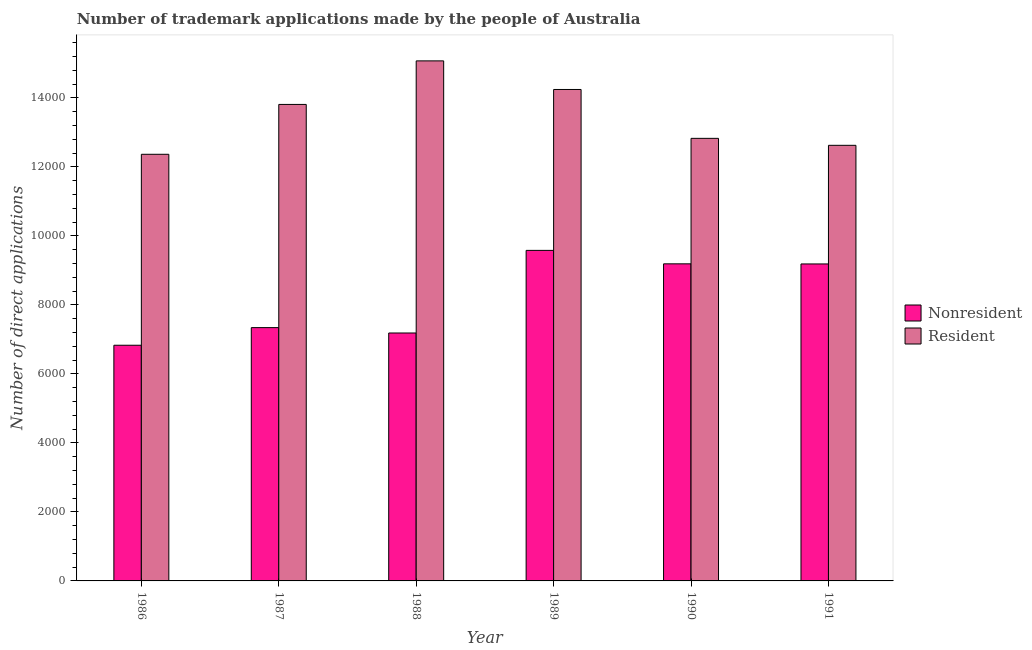How many groups of bars are there?
Provide a succinct answer. 6. Are the number of bars on each tick of the X-axis equal?
Make the answer very short. Yes. In how many cases, is the number of bars for a given year not equal to the number of legend labels?
Make the answer very short. 0. What is the number of trademark applications made by residents in 1987?
Your answer should be compact. 1.38e+04. Across all years, what is the maximum number of trademark applications made by residents?
Make the answer very short. 1.51e+04. Across all years, what is the minimum number of trademark applications made by non residents?
Your answer should be very brief. 6830. What is the total number of trademark applications made by residents in the graph?
Give a very brief answer. 8.09e+04. What is the difference between the number of trademark applications made by residents in 1987 and that in 1988?
Keep it short and to the point. -1262. What is the difference between the number of trademark applications made by residents in 1987 and the number of trademark applications made by non residents in 1989?
Your answer should be very brief. -433. What is the average number of trademark applications made by residents per year?
Make the answer very short. 1.35e+04. In the year 1986, what is the difference between the number of trademark applications made by residents and number of trademark applications made by non residents?
Give a very brief answer. 0. In how many years, is the number of trademark applications made by residents greater than 7600?
Give a very brief answer. 6. What is the ratio of the number of trademark applications made by non residents in 1986 to that in 1989?
Provide a short and direct response. 0.71. Is the difference between the number of trademark applications made by residents in 1988 and 1990 greater than the difference between the number of trademark applications made by non residents in 1988 and 1990?
Your response must be concise. No. What is the difference between the highest and the second highest number of trademark applications made by non residents?
Ensure brevity in your answer.  390. What is the difference between the highest and the lowest number of trademark applications made by residents?
Provide a short and direct response. 2707. Is the sum of the number of trademark applications made by non residents in 1986 and 1987 greater than the maximum number of trademark applications made by residents across all years?
Provide a short and direct response. Yes. What does the 1st bar from the left in 1987 represents?
Ensure brevity in your answer.  Nonresident. What does the 2nd bar from the right in 1987 represents?
Your response must be concise. Nonresident. What is the difference between two consecutive major ticks on the Y-axis?
Ensure brevity in your answer.  2000. Are the values on the major ticks of Y-axis written in scientific E-notation?
Your response must be concise. No. Does the graph contain grids?
Offer a very short reply. No. Where does the legend appear in the graph?
Provide a short and direct response. Center right. How many legend labels are there?
Offer a very short reply. 2. What is the title of the graph?
Ensure brevity in your answer.  Number of trademark applications made by the people of Australia. Does "From production" appear as one of the legend labels in the graph?
Your answer should be very brief. No. What is the label or title of the Y-axis?
Your answer should be compact. Number of direct applications. What is the Number of direct applications in Nonresident in 1986?
Make the answer very short. 6830. What is the Number of direct applications of Resident in 1986?
Keep it short and to the point. 1.24e+04. What is the Number of direct applications of Nonresident in 1987?
Offer a terse response. 7341. What is the Number of direct applications in Resident in 1987?
Your response must be concise. 1.38e+04. What is the Number of direct applications in Nonresident in 1988?
Your answer should be compact. 7185. What is the Number of direct applications of Resident in 1988?
Your answer should be very brief. 1.51e+04. What is the Number of direct applications of Nonresident in 1989?
Your answer should be compact. 9579. What is the Number of direct applications of Resident in 1989?
Offer a terse response. 1.42e+04. What is the Number of direct applications of Nonresident in 1990?
Offer a terse response. 9189. What is the Number of direct applications in Resident in 1990?
Keep it short and to the point. 1.28e+04. What is the Number of direct applications in Nonresident in 1991?
Give a very brief answer. 9186. What is the Number of direct applications of Resident in 1991?
Offer a terse response. 1.26e+04. Across all years, what is the maximum Number of direct applications in Nonresident?
Offer a very short reply. 9579. Across all years, what is the maximum Number of direct applications of Resident?
Give a very brief answer. 1.51e+04. Across all years, what is the minimum Number of direct applications in Nonresident?
Keep it short and to the point. 6830. Across all years, what is the minimum Number of direct applications of Resident?
Offer a terse response. 1.24e+04. What is the total Number of direct applications in Nonresident in the graph?
Give a very brief answer. 4.93e+04. What is the total Number of direct applications in Resident in the graph?
Your response must be concise. 8.09e+04. What is the difference between the Number of direct applications of Nonresident in 1986 and that in 1987?
Your response must be concise. -511. What is the difference between the Number of direct applications in Resident in 1986 and that in 1987?
Offer a terse response. -1445. What is the difference between the Number of direct applications in Nonresident in 1986 and that in 1988?
Your answer should be compact. -355. What is the difference between the Number of direct applications in Resident in 1986 and that in 1988?
Provide a short and direct response. -2707. What is the difference between the Number of direct applications in Nonresident in 1986 and that in 1989?
Your answer should be compact. -2749. What is the difference between the Number of direct applications in Resident in 1986 and that in 1989?
Provide a short and direct response. -1878. What is the difference between the Number of direct applications of Nonresident in 1986 and that in 1990?
Make the answer very short. -2359. What is the difference between the Number of direct applications in Resident in 1986 and that in 1990?
Provide a short and direct response. -462. What is the difference between the Number of direct applications in Nonresident in 1986 and that in 1991?
Give a very brief answer. -2356. What is the difference between the Number of direct applications in Resident in 1986 and that in 1991?
Make the answer very short. -260. What is the difference between the Number of direct applications of Nonresident in 1987 and that in 1988?
Keep it short and to the point. 156. What is the difference between the Number of direct applications in Resident in 1987 and that in 1988?
Provide a short and direct response. -1262. What is the difference between the Number of direct applications in Nonresident in 1987 and that in 1989?
Your answer should be compact. -2238. What is the difference between the Number of direct applications in Resident in 1987 and that in 1989?
Provide a succinct answer. -433. What is the difference between the Number of direct applications of Nonresident in 1987 and that in 1990?
Your answer should be compact. -1848. What is the difference between the Number of direct applications of Resident in 1987 and that in 1990?
Your answer should be very brief. 983. What is the difference between the Number of direct applications of Nonresident in 1987 and that in 1991?
Your response must be concise. -1845. What is the difference between the Number of direct applications of Resident in 1987 and that in 1991?
Ensure brevity in your answer.  1185. What is the difference between the Number of direct applications of Nonresident in 1988 and that in 1989?
Offer a terse response. -2394. What is the difference between the Number of direct applications in Resident in 1988 and that in 1989?
Provide a short and direct response. 829. What is the difference between the Number of direct applications in Nonresident in 1988 and that in 1990?
Your answer should be compact. -2004. What is the difference between the Number of direct applications of Resident in 1988 and that in 1990?
Make the answer very short. 2245. What is the difference between the Number of direct applications of Nonresident in 1988 and that in 1991?
Provide a short and direct response. -2001. What is the difference between the Number of direct applications in Resident in 1988 and that in 1991?
Provide a short and direct response. 2447. What is the difference between the Number of direct applications of Nonresident in 1989 and that in 1990?
Make the answer very short. 390. What is the difference between the Number of direct applications of Resident in 1989 and that in 1990?
Your answer should be very brief. 1416. What is the difference between the Number of direct applications in Nonresident in 1989 and that in 1991?
Provide a short and direct response. 393. What is the difference between the Number of direct applications in Resident in 1989 and that in 1991?
Provide a short and direct response. 1618. What is the difference between the Number of direct applications of Nonresident in 1990 and that in 1991?
Your response must be concise. 3. What is the difference between the Number of direct applications of Resident in 1990 and that in 1991?
Your answer should be very brief. 202. What is the difference between the Number of direct applications in Nonresident in 1986 and the Number of direct applications in Resident in 1987?
Your answer should be compact. -6979. What is the difference between the Number of direct applications in Nonresident in 1986 and the Number of direct applications in Resident in 1988?
Offer a very short reply. -8241. What is the difference between the Number of direct applications of Nonresident in 1986 and the Number of direct applications of Resident in 1989?
Offer a terse response. -7412. What is the difference between the Number of direct applications of Nonresident in 1986 and the Number of direct applications of Resident in 1990?
Keep it short and to the point. -5996. What is the difference between the Number of direct applications of Nonresident in 1986 and the Number of direct applications of Resident in 1991?
Ensure brevity in your answer.  -5794. What is the difference between the Number of direct applications in Nonresident in 1987 and the Number of direct applications in Resident in 1988?
Make the answer very short. -7730. What is the difference between the Number of direct applications in Nonresident in 1987 and the Number of direct applications in Resident in 1989?
Your answer should be very brief. -6901. What is the difference between the Number of direct applications of Nonresident in 1987 and the Number of direct applications of Resident in 1990?
Offer a very short reply. -5485. What is the difference between the Number of direct applications in Nonresident in 1987 and the Number of direct applications in Resident in 1991?
Provide a short and direct response. -5283. What is the difference between the Number of direct applications of Nonresident in 1988 and the Number of direct applications of Resident in 1989?
Keep it short and to the point. -7057. What is the difference between the Number of direct applications in Nonresident in 1988 and the Number of direct applications in Resident in 1990?
Provide a succinct answer. -5641. What is the difference between the Number of direct applications in Nonresident in 1988 and the Number of direct applications in Resident in 1991?
Give a very brief answer. -5439. What is the difference between the Number of direct applications in Nonresident in 1989 and the Number of direct applications in Resident in 1990?
Ensure brevity in your answer.  -3247. What is the difference between the Number of direct applications in Nonresident in 1989 and the Number of direct applications in Resident in 1991?
Your answer should be very brief. -3045. What is the difference between the Number of direct applications in Nonresident in 1990 and the Number of direct applications in Resident in 1991?
Give a very brief answer. -3435. What is the average Number of direct applications in Nonresident per year?
Your response must be concise. 8218.33. What is the average Number of direct applications in Resident per year?
Provide a short and direct response. 1.35e+04. In the year 1986, what is the difference between the Number of direct applications in Nonresident and Number of direct applications in Resident?
Give a very brief answer. -5534. In the year 1987, what is the difference between the Number of direct applications of Nonresident and Number of direct applications of Resident?
Make the answer very short. -6468. In the year 1988, what is the difference between the Number of direct applications of Nonresident and Number of direct applications of Resident?
Your response must be concise. -7886. In the year 1989, what is the difference between the Number of direct applications of Nonresident and Number of direct applications of Resident?
Your response must be concise. -4663. In the year 1990, what is the difference between the Number of direct applications in Nonresident and Number of direct applications in Resident?
Make the answer very short. -3637. In the year 1991, what is the difference between the Number of direct applications of Nonresident and Number of direct applications of Resident?
Your answer should be compact. -3438. What is the ratio of the Number of direct applications of Nonresident in 1986 to that in 1987?
Provide a short and direct response. 0.93. What is the ratio of the Number of direct applications of Resident in 1986 to that in 1987?
Your answer should be very brief. 0.9. What is the ratio of the Number of direct applications in Nonresident in 1986 to that in 1988?
Keep it short and to the point. 0.95. What is the ratio of the Number of direct applications in Resident in 1986 to that in 1988?
Offer a terse response. 0.82. What is the ratio of the Number of direct applications of Nonresident in 1986 to that in 1989?
Your answer should be compact. 0.71. What is the ratio of the Number of direct applications of Resident in 1986 to that in 1989?
Your response must be concise. 0.87. What is the ratio of the Number of direct applications in Nonresident in 1986 to that in 1990?
Make the answer very short. 0.74. What is the ratio of the Number of direct applications in Nonresident in 1986 to that in 1991?
Keep it short and to the point. 0.74. What is the ratio of the Number of direct applications of Resident in 1986 to that in 1991?
Offer a very short reply. 0.98. What is the ratio of the Number of direct applications of Nonresident in 1987 to that in 1988?
Offer a terse response. 1.02. What is the ratio of the Number of direct applications of Resident in 1987 to that in 1988?
Offer a terse response. 0.92. What is the ratio of the Number of direct applications in Nonresident in 1987 to that in 1989?
Your answer should be very brief. 0.77. What is the ratio of the Number of direct applications in Resident in 1987 to that in 1989?
Offer a terse response. 0.97. What is the ratio of the Number of direct applications in Nonresident in 1987 to that in 1990?
Your response must be concise. 0.8. What is the ratio of the Number of direct applications in Resident in 1987 to that in 1990?
Keep it short and to the point. 1.08. What is the ratio of the Number of direct applications in Nonresident in 1987 to that in 1991?
Your answer should be very brief. 0.8. What is the ratio of the Number of direct applications in Resident in 1987 to that in 1991?
Your answer should be very brief. 1.09. What is the ratio of the Number of direct applications in Nonresident in 1988 to that in 1989?
Keep it short and to the point. 0.75. What is the ratio of the Number of direct applications of Resident in 1988 to that in 1989?
Your response must be concise. 1.06. What is the ratio of the Number of direct applications in Nonresident in 1988 to that in 1990?
Your answer should be compact. 0.78. What is the ratio of the Number of direct applications in Resident in 1988 to that in 1990?
Give a very brief answer. 1.18. What is the ratio of the Number of direct applications of Nonresident in 1988 to that in 1991?
Your answer should be very brief. 0.78. What is the ratio of the Number of direct applications of Resident in 1988 to that in 1991?
Offer a very short reply. 1.19. What is the ratio of the Number of direct applications of Nonresident in 1989 to that in 1990?
Provide a short and direct response. 1.04. What is the ratio of the Number of direct applications in Resident in 1989 to that in 1990?
Your response must be concise. 1.11. What is the ratio of the Number of direct applications of Nonresident in 1989 to that in 1991?
Provide a succinct answer. 1.04. What is the ratio of the Number of direct applications of Resident in 1989 to that in 1991?
Ensure brevity in your answer.  1.13. What is the ratio of the Number of direct applications of Nonresident in 1990 to that in 1991?
Your answer should be compact. 1. What is the difference between the highest and the second highest Number of direct applications of Nonresident?
Make the answer very short. 390. What is the difference between the highest and the second highest Number of direct applications in Resident?
Provide a short and direct response. 829. What is the difference between the highest and the lowest Number of direct applications of Nonresident?
Your answer should be compact. 2749. What is the difference between the highest and the lowest Number of direct applications in Resident?
Ensure brevity in your answer.  2707. 